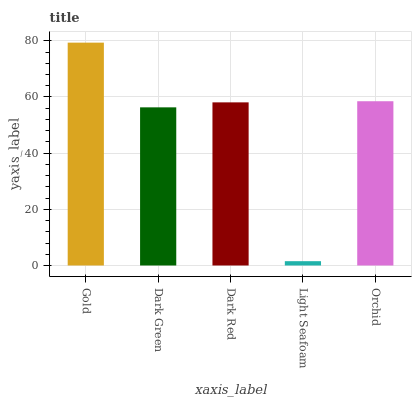Is Light Seafoam the minimum?
Answer yes or no. Yes. Is Gold the maximum?
Answer yes or no. Yes. Is Dark Green the minimum?
Answer yes or no. No. Is Dark Green the maximum?
Answer yes or no. No. Is Gold greater than Dark Green?
Answer yes or no. Yes. Is Dark Green less than Gold?
Answer yes or no. Yes. Is Dark Green greater than Gold?
Answer yes or no. No. Is Gold less than Dark Green?
Answer yes or no. No. Is Dark Red the high median?
Answer yes or no. Yes. Is Dark Red the low median?
Answer yes or no. Yes. Is Dark Green the high median?
Answer yes or no. No. Is Gold the low median?
Answer yes or no. No. 